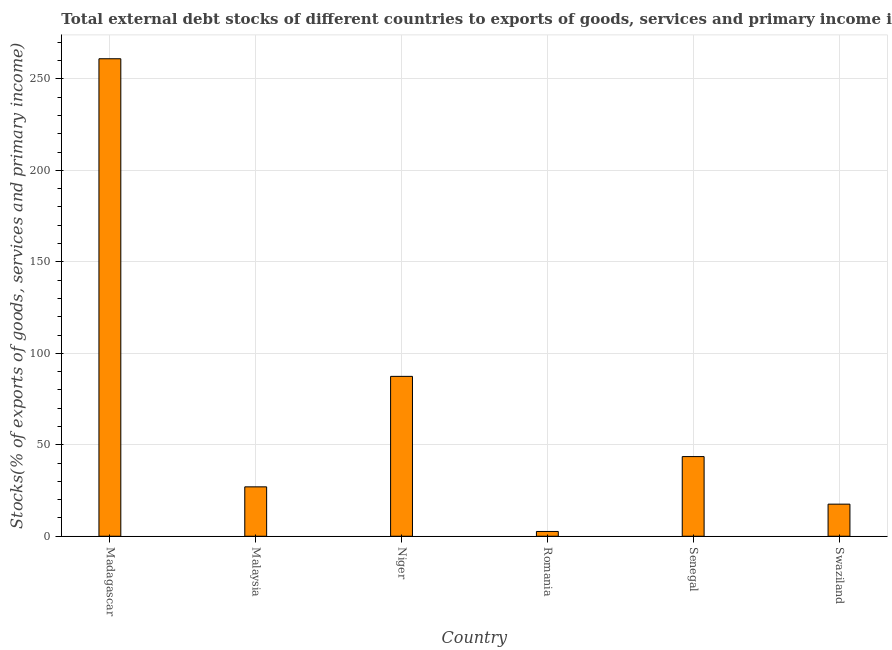Does the graph contain any zero values?
Your answer should be compact. No. What is the title of the graph?
Offer a terse response. Total external debt stocks of different countries to exports of goods, services and primary income in 1974. What is the label or title of the Y-axis?
Provide a short and direct response. Stocks(% of exports of goods, services and primary income). What is the external debt stocks in Niger?
Give a very brief answer. 87.4. Across all countries, what is the maximum external debt stocks?
Your response must be concise. 261.02. Across all countries, what is the minimum external debt stocks?
Ensure brevity in your answer.  2.62. In which country was the external debt stocks maximum?
Ensure brevity in your answer.  Madagascar. In which country was the external debt stocks minimum?
Offer a terse response. Romania. What is the sum of the external debt stocks?
Offer a terse response. 439.14. What is the difference between the external debt stocks in Madagascar and Swaziland?
Provide a short and direct response. 243.47. What is the average external debt stocks per country?
Offer a very short reply. 73.19. What is the median external debt stocks?
Keep it short and to the point. 35.27. What is the ratio of the external debt stocks in Madagascar to that in Niger?
Keep it short and to the point. 2.99. What is the difference between the highest and the second highest external debt stocks?
Give a very brief answer. 173.62. Is the sum of the external debt stocks in Senegal and Swaziland greater than the maximum external debt stocks across all countries?
Your answer should be very brief. No. What is the difference between the highest and the lowest external debt stocks?
Make the answer very short. 258.4. How many countries are there in the graph?
Ensure brevity in your answer.  6. What is the Stocks(% of exports of goods, services and primary income) of Madagascar?
Offer a terse response. 261.02. What is the Stocks(% of exports of goods, services and primary income) in Malaysia?
Keep it short and to the point. 27. What is the Stocks(% of exports of goods, services and primary income) of Niger?
Your answer should be compact. 87.4. What is the Stocks(% of exports of goods, services and primary income) of Romania?
Offer a very short reply. 2.62. What is the Stocks(% of exports of goods, services and primary income) in Senegal?
Your answer should be compact. 43.55. What is the Stocks(% of exports of goods, services and primary income) of Swaziland?
Ensure brevity in your answer.  17.55. What is the difference between the Stocks(% of exports of goods, services and primary income) in Madagascar and Malaysia?
Your response must be concise. 234.02. What is the difference between the Stocks(% of exports of goods, services and primary income) in Madagascar and Niger?
Your answer should be very brief. 173.62. What is the difference between the Stocks(% of exports of goods, services and primary income) in Madagascar and Romania?
Provide a short and direct response. 258.4. What is the difference between the Stocks(% of exports of goods, services and primary income) in Madagascar and Senegal?
Provide a short and direct response. 217.48. What is the difference between the Stocks(% of exports of goods, services and primary income) in Madagascar and Swaziland?
Offer a terse response. 243.47. What is the difference between the Stocks(% of exports of goods, services and primary income) in Malaysia and Niger?
Keep it short and to the point. -60.4. What is the difference between the Stocks(% of exports of goods, services and primary income) in Malaysia and Romania?
Keep it short and to the point. 24.38. What is the difference between the Stocks(% of exports of goods, services and primary income) in Malaysia and Senegal?
Provide a short and direct response. -16.54. What is the difference between the Stocks(% of exports of goods, services and primary income) in Malaysia and Swaziland?
Give a very brief answer. 9.45. What is the difference between the Stocks(% of exports of goods, services and primary income) in Niger and Romania?
Make the answer very short. 84.78. What is the difference between the Stocks(% of exports of goods, services and primary income) in Niger and Senegal?
Offer a very short reply. 43.85. What is the difference between the Stocks(% of exports of goods, services and primary income) in Niger and Swaziland?
Give a very brief answer. 69.85. What is the difference between the Stocks(% of exports of goods, services and primary income) in Romania and Senegal?
Offer a very short reply. -40.93. What is the difference between the Stocks(% of exports of goods, services and primary income) in Romania and Swaziland?
Your answer should be very brief. -14.93. What is the difference between the Stocks(% of exports of goods, services and primary income) in Senegal and Swaziland?
Give a very brief answer. 26. What is the ratio of the Stocks(% of exports of goods, services and primary income) in Madagascar to that in Malaysia?
Your answer should be very brief. 9.67. What is the ratio of the Stocks(% of exports of goods, services and primary income) in Madagascar to that in Niger?
Make the answer very short. 2.99. What is the ratio of the Stocks(% of exports of goods, services and primary income) in Madagascar to that in Romania?
Ensure brevity in your answer.  99.59. What is the ratio of the Stocks(% of exports of goods, services and primary income) in Madagascar to that in Senegal?
Make the answer very short. 5.99. What is the ratio of the Stocks(% of exports of goods, services and primary income) in Madagascar to that in Swaziland?
Give a very brief answer. 14.87. What is the ratio of the Stocks(% of exports of goods, services and primary income) in Malaysia to that in Niger?
Offer a very short reply. 0.31. What is the ratio of the Stocks(% of exports of goods, services and primary income) in Malaysia to that in Romania?
Your response must be concise. 10.3. What is the ratio of the Stocks(% of exports of goods, services and primary income) in Malaysia to that in Senegal?
Your answer should be compact. 0.62. What is the ratio of the Stocks(% of exports of goods, services and primary income) in Malaysia to that in Swaziland?
Provide a short and direct response. 1.54. What is the ratio of the Stocks(% of exports of goods, services and primary income) in Niger to that in Romania?
Ensure brevity in your answer.  33.35. What is the ratio of the Stocks(% of exports of goods, services and primary income) in Niger to that in Senegal?
Make the answer very short. 2.01. What is the ratio of the Stocks(% of exports of goods, services and primary income) in Niger to that in Swaziland?
Your answer should be compact. 4.98. What is the ratio of the Stocks(% of exports of goods, services and primary income) in Romania to that in Senegal?
Provide a succinct answer. 0.06. What is the ratio of the Stocks(% of exports of goods, services and primary income) in Romania to that in Swaziland?
Provide a short and direct response. 0.15. What is the ratio of the Stocks(% of exports of goods, services and primary income) in Senegal to that in Swaziland?
Offer a very short reply. 2.48. 